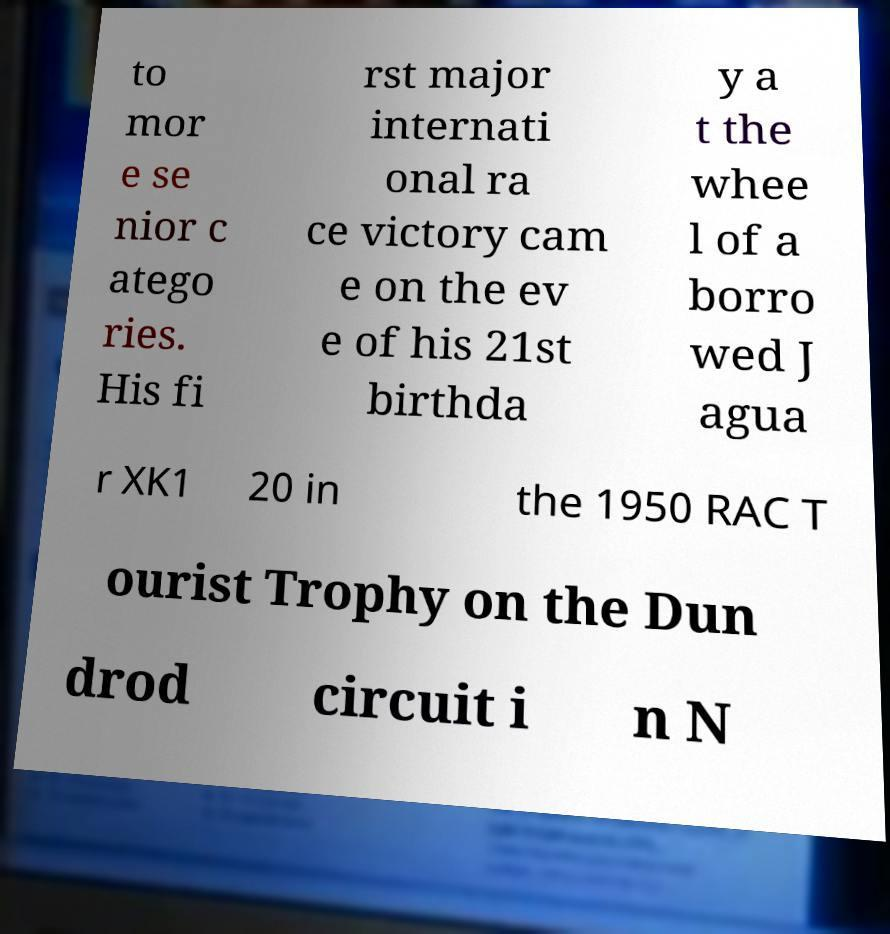Can you read and provide the text displayed in the image?This photo seems to have some interesting text. Can you extract and type it out for me? to mor e se nior c atego ries. His fi rst major internati onal ra ce victory cam e on the ev e of his 21st birthda y a t the whee l of a borro wed J agua r XK1 20 in the 1950 RAC T ourist Trophy on the Dun drod circuit i n N 